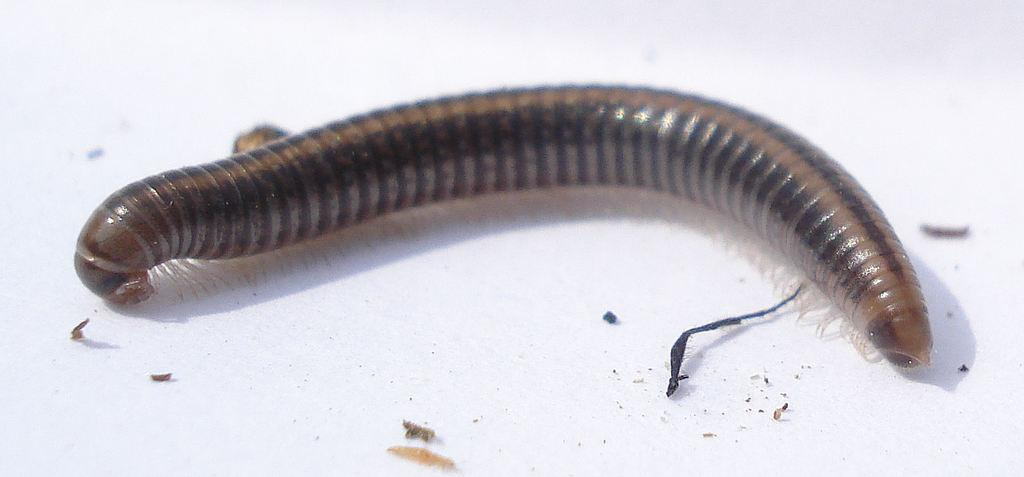What type of animal is in the image? There is an earthworm in the image. What is the earthworm resting on in the image? The earthworm is on a white surface. What type of crib is visible in the image? There is no crib present in the image; it only features an earthworm on a white surface. 